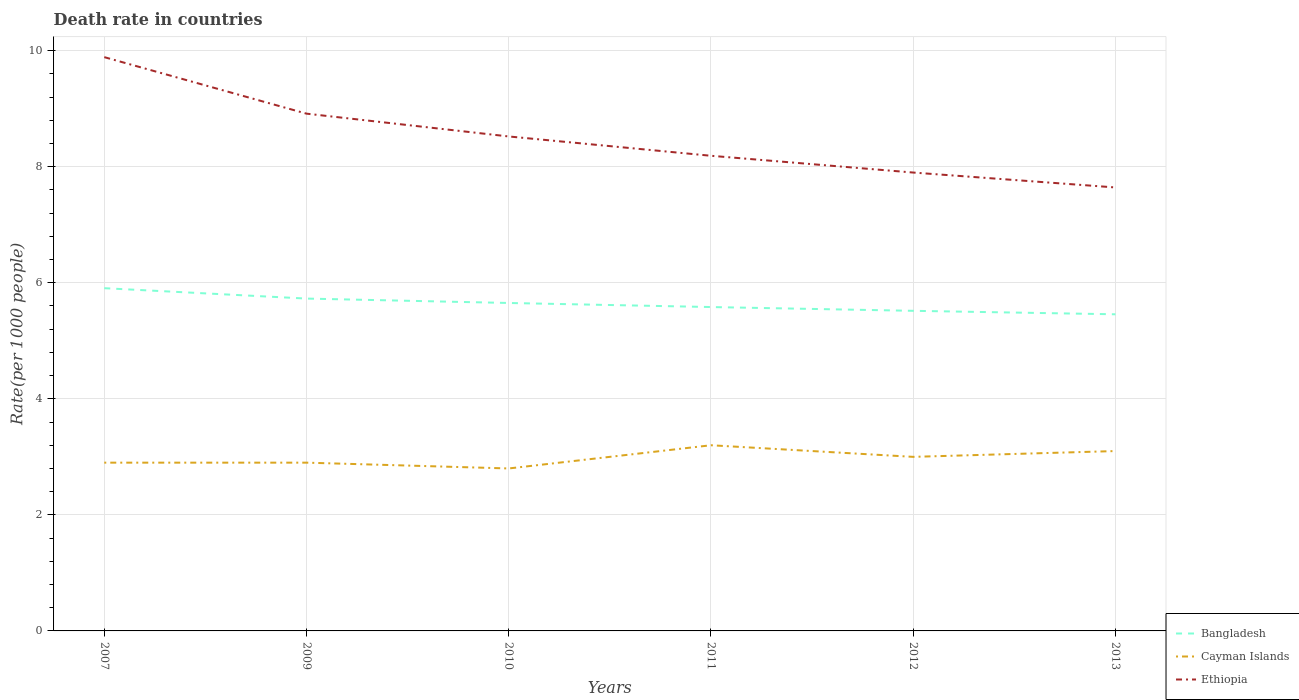How many different coloured lines are there?
Give a very brief answer. 3. Does the line corresponding to Bangladesh intersect with the line corresponding to Ethiopia?
Offer a terse response. No. Is the number of lines equal to the number of legend labels?
Ensure brevity in your answer.  Yes. Across all years, what is the maximum death rate in Cayman Islands?
Offer a very short reply. 2.8. In which year was the death rate in Cayman Islands maximum?
Ensure brevity in your answer.  2010. What is the total death rate in Cayman Islands in the graph?
Make the answer very short. -0.3. What is the difference between the highest and the second highest death rate in Bangladesh?
Make the answer very short. 0.45. How many years are there in the graph?
Offer a very short reply. 6. Are the values on the major ticks of Y-axis written in scientific E-notation?
Give a very brief answer. No. Does the graph contain any zero values?
Your response must be concise. No. Does the graph contain grids?
Give a very brief answer. Yes. What is the title of the graph?
Make the answer very short. Death rate in countries. What is the label or title of the Y-axis?
Offer a very short reply. Rate(per 1000 people). What is the Rate(per 1000 people) in Bangladesh in 2007?
Provide a succinct answer. 5.91. What is the Rate(per 1000 people) of Cayman Islands in 2007?
Keep it short and to the point. 2.9. What is the Rate(per 1000 people) in Ethiopia in 2007?
Your response must be concise. 9.89. What is the Rate(per 1000 people) of Bangladesh in 2009?
Your answer should be very brief. 5.73. What is the Rate(per 1000 people) in Cayman Islands in 2009?
Make the answer very short. 2.9. What is the Rate(per 1000 people) in Ethiopia in 2009?
Provide a short and direct response. 8.91. What is the Rate(per 1000 people) of Bangladesh in 2010?
Provide a short and direct response. 5.65. What is the Rate(per 1000 people) in Cayman Islands in 2010?
Keep it short and to the point. 2.8. What is the Rate(per 1000 people) of Ethiopia in 2010?
Offer a very short reply. 8.52. What is the Rate(per 1000 people) in Bangladesh in 2011?
Your answer should be very brief. 5.58. What is the Rate(per 1000 people) in Cayman Islands in 2011?
Keep it short and to the point. 3.2. What is the Rate(per 1000 people) in Ethiopia in 2011?
Your answer should be very brief. 8.19. What is the Rate(per 1000 people) of Bangladesh in 2012?
Offer a very short reply. 5.52. What is the Rate(per 1000 people) in Ethiopia in 2012?
Make the answer very short. 7.9. What is the Rate(per 1000 people) in Bangladesh in 2013?
Offer a very short reply. 5.46. What is the Rate(per 1000 people) in Ethiopia in 2013?
Provide a short and direct response. 7.64. Across all years, what is the maximum Rate(per 1000 people) in Bangladesh?
Your answer should be compact. 5.91. Across all years, what is the maximum Rate(per 1000 people) of Cayman Islands?
Give a very brief answer. 3.2. Across all years, what is the maximum Rate(per 1000 people) of Ethiopia?
Offer a terse response. 9.89. Across all years, what is the minimum Rate(per 1000 people) of Bangladesh?
Offer a very short reply. 5.46. Across all years, what is the minimum Rate(per 1000 people) in Ethiopia?
Your answer should be very brief. 7.64. What is the total Rate(per 1000 people) of Bangladesh in the graph?
Provide a succinct answer. 33.84. What is the total Rate(per 1000 people) in Cayman Islands in the graph?
Give a very brief answer. 17.9. What is the total Rate(per 1000 people) of Ethiopia in the graph?
Provide a short and direct response. 51.06. What is the difference between the Rate(per 1000 people) in Bangladesh in 2007 and that in 2009?
Provide a succinct answer. 0.18. What is the difference between the Rate(per 1000 people) of Cayman Islands in 2007 and that in 2009?
Provide a short and direct response. 0. What is the difference between the Rate(per 1000 people) in Ethiopia in 2007 and that in 2009?
Keep it short and to the point. 0.97. What is the difference between the Rate(per 1000 people) in Bangladesh in 2007 and that in 2010?
Your response must be concise. 0.26. What is the difference between the Rate(per 1000 people) of Ethiopia in 2007 and that in 2010?
Offer a very short reply. 1.37. What is the difference between the Rate(per 1000 people) of Bangladesh in 2007 and that in 2011?
Offer a very short reply. 0.33. What is the difference between the Rate(per 1000 people) of Cayman Islands in 2007 and that in 2011?
Provide a short and direct response. -0.3. What is the difference between the Rate(per 1000 people) in Ethiopia in 2007 and that in 2011?
Keep it short and to the point. 1.7. What is the difference between the Rate(per 1000 people) of Bangladesh in 2007 and that in 2012?
Your response must be concise. 0.39. What is the difference between the Rate(per 1000 people) in Cayman Islands in 2007 and that in 2012?
Offer a terse response. -0.1. What is the difference between the Rate(per 1000 people) of Ethiopia in 2007 and that in 2012?
Provide a succinct answer. 1.99. What is the difference between the Rate(per 1000 people) of Bangladesh in 2007 and that in 2013?
Keep it short and to the point. 0.45. What is the difference between the Rate(per 1000 people) of Ethiopia in 2007 and that in 2013?
Give a very brief answer. 2.25. What is the difference between the Rate(per 1000 people) in Bangladesh in 2009 and that in 2010?
Make the answer very short. 0.08. What is the difference between the Rate(per 1000 people) in Cayman Islands in 2009 and that in 2010?
Make the answer very short. 0.1. What is the difference between the Rate(per 1000 people) of Ethiopia in 2009 and that in 2010?
Make the answer very short. 0.39. What is the difference between the Rate(per 1000 people) in Bangladesh in 2009 and that in 2011?
Your response must be concise. 0.15. What is the difference between the Rate(per 1000 people) of Cayman Islands in 2009 and that in 2011?
Your answer should be compact. -0.3. What is the difference between the Rate(per 1000 people) in Ethiopia in 2009 and that in 2011?
Your answer should be very brief. 0.73. What is the difference between the Rate(per 1000 people) in Bangladesh in 2009 and that in 2012?
Provide a succinct answer. 0.21. What is the difference between the Rate(per 1000 people) in Cayman Islands in 2009 and that in 2012?
Offer a very short reply. -0.1. What is the difference between the Rate(per 1000 people) of Bangladesh in 2009 and that in 2013?
Offer a very short reply. 0.27. What is the difference between the Rate(per 1000 people) of Cayman Islands in 2009 and that in 2013?
Your answer should be compact. -0.2. What is the difference between the Rate(per 1000 people) of Ethiopia in 2009 and that in 2013?
Give a very brief answer. 1.27. What is the difference between the Rate(per 1000 people) in Bangladesh in 2010 and that in 2011?
Ensure brevity in your answer.  0.07. What is the difference between the Rate(per 1000 people) of Cayman Islands in 2010 and that in 2011?
Ensure brevity in your answer.  -0.4. What is the difference between the Rate(per 1000 people) in Ethiopia in 2010 and that in 2011?
Keep it short and to the point. 0.33. What is the difference between the Rate(per 1000 people) in Bangladesh in 2010 and that in 2012?
Give a very brief answer. 0.14. What is the difference between the Rate(per 1000 people) of Cayman Islands in 2010 and that in 2012?
Offer a very short reply. -0.2. What is the difference between the Rate(per 1000 people) of Ethiopia in 2010 and that in 2012?
Offer a very short reply. 0.62. What is the difference between the Rate(per 1000 people) in Bangladesh in 2010 and that in 2013?
Make the answer very short. 0.2. What is the difference between the Rate(per 1000 people) of Ethiopia in 2010 and that in 2013?
Give a very brief answer. 0.88. What is the difference between the Rate(per 1000 people) in Bangladesh in 2011 and that in 2012?
Provide a succinct answer. 0.07. What is the difference between the Rate(per 1000 people) of Ethiopia in 2011 and that in 2012?
Keep it short and to the point. 0.29. What is the difference between the Rate(per 1000 people) in Bangladesh in 2011 and that in 2013?
Your response must be concise. 0.12. What is the difference between the Rate(per 1000 people) in Ethiopia in 2011 and that in 2013?
Your answer should be compact. 0.55. What is the difference between the Rate(per 1000 people) in Bangladesh in 2012 and that in 2013?
Offer a very short reply. 0.06. What is the difference between the Rate(per 1000 people) of Cayman Islands in 2012 and that in 2013?
Your answer should be very brief. -0.1. What is the difference between the Rate(per 1000 people) in Ethiopia in 2012 and that in 2013?
Make the answer very short. 0.26. What is the difference between the Rate(per 1000 people) of Bangladesh in 2007 and the Rate(per 1000 people) of Cayman Islands in 2009?
Offer a very short reply. 3.01. What is the difference between the Rate(per 1000 people) in Bangladesh in 2007 and the Rate(per 1000 people) in Ethiopia in 2009?
Ensure brevity in your answer.  -3.01. What is the difference between the Rate(per 1000 people) in Cayman Islands in 2007 and the Rate(per 1000 people) in Ethiopia in 2009?
Your answer should be compact. -6.01. What is the difference between the Rate(per 1000 people) in Bangladesh in 2007 and the Rate(per 1000 people) in Cayman Islands in 2010?
Provide a short and direct response. 3.11. What is the difference between the Rate(per 1000 people) in Bangladesh in 2007 and the Rate(per 1000 people) in Ethiopia in 2010?
Offer a terse response. -2.62. What is the difference between the Rate(per 1000 people) of Cayman Islands in 2007 and the Rate(per 1000 people) of Ethiopia in 2010?
Give a very brief answer. -5.62. What is the difference between the Rate(per 1000 people) in Bangladesh in 2007 and the Rate(per 1000 people) in Cayman Islands in 2011?
Offer a very short reply. 2.71. What is the difference between the Rate(per 1000 people) of Bangladesh in 2007 and the Rate(per 1000 people) of Ethiopia in 2011?
Provide a short and direct response. -2.28. What is the difference between the Rate(per 1000 people) of Cayman Islands in 2007 and the Rate(per 1000 people) of Ethiopia in 2011?
Offer a very short reply. -5.29. What is the difference between the Rate(per 1000 people) of Bangladesh in 2007 and the Rate(per 1000 people) of Cayman Islands in 2012?
Make the answer very short. 2.91. What is the difference between the Rate(per 1000 people) in Bangladesh in 2007 and the Rate(per 1000 people) in Ethiopia in 2012?
Provide a succinct answer. -1.99. What is the difference between the Rate(per 1000 people) in Bangladesh in 2007 and the Rate(per 1000 people) in Cayman Islands in 2013?
Keep it short and to the point. 2.81. What is the difference between the Rate(per 1000 people) in Bangladesh in 2007 and the Rate(per 1000 people) in Ethiopia in 2013?
Make the answer very short. -1.74. What is the difference between the Rate(per 1000 people) of Cayman Islands in 2007 and the Rate(per 1000 people) of Ethiopia in 2013?
Your answer should be compact. -4.74. What is the difference between the Rate(per 1000 people) of Bangladesh in 2009 and the Rate(per 1000 people) of Cayman Islands in 2010?
Keep it short and to the point. 2.93. What is the difference between the Rate(per 1000 people) of Bangladesh in 2009 and the Rate(per 1000 people) of Ethiopia in 2010?
Your response must be concise. -2.79. What is the difference between the Rate(per 1000 people) in Cayman Islands in 2009 and the Rate(per 1000 people) in Ethiopia in 2010?
Your response must be concise. -5.62. What is the difference between the Rate(per 1000 people) of Bangladesh in 2009 and the Rate(per 1000 people) of Cayman Islands in 2011?
Your response must be concise. 2.53. What is the difference between the Rate(per 1000 people) in Bangladesh in 2009 and the Rate(per 1000 people) in Ethiopia in 2011?
Provide a short and direct response. -2.46. What is the difference between the Rate(per 1000 people) in Cayman Islands in 2009 and the Rate(per 1000 people) in Ethiopia in 2011?
Make the answer very short. -5.29. What is the difference between the Rate(per 1000 people) in Bangladesh in 2009 and the Rate(per 1000 people) in Cayman Islands in 2012?
Offer a terse response. 2.73. What is the difference between the Rate(per 1000 people) of Bangladesh in 2009 and the Rate(per 1000 people) of Ethiopia in 2012?
Your answer should be very brief. -2.17. What is the difference between the Rate(per 1000 people) of Bangladesh in 2009 and the Rate(per 1000 people) of Cayman Islands in 2013?
Offer a very short reply. 2.63. What is the difference between the Rate(per 1000 people) of Bangladesh in 2009 and the Rate(per 1000 people) of Ethiopia in 2013?
Your response must be concise. -1.92. What is the difference between the Rate(per 1000 people) in Cayman Islands in 2009 and the Rate(per 1000 people) in Ethiopia in 2013?
Make the answer very short. -4.74. What is the difference between the Rate(per 1000 people) of Bangladesh in 2010 and the Rate(per 1000 people) of Cayman Islands in 2011?
Provide a succinct answer. 2.45. What is the difference between the Rate(per 1000 people) in Bangladesh in 2010 and the Rate(per 1000 people) in Ethiopia in 2011?
Keep it short and to the point. -2.54. What is the difference between the Rate(per 1000 people) of Cayman Islands in 2010 and the Rate(per 1000 people) of Ethiopia in 2011?
Offer a very short reply. -5.39. What is the difference between the Rate(per 1000 people) of Bangladesh in 2010 and the Rate(per 1000 people) of Cayman Islands in 2012?
Your answer should be very brief. 2.65. What is the difference between the Rate(per 1000 people) in Bangladesh in 2010 and the Rate(per 1000 people) in Ethiopia in 2012?
Your response must be concise. -2.25. What is the difference between the Rate(per 1000 people) of Bangladesh in 2010 and the Rate(per 1000 people) of Cayman Islands in 2013?
Your answer should be compact. 2.55. What is the difference between the Rate(per 1000 people) in Bangladesh in 2010 and the Rate(per 1000 people) in Ethiopia in 2013?
Provide a succinct answer. -1.99. What is the difference between the Rate(per 1000 people) in Cayman Islands in 2010 and the Rate(per 1000 people) in Ethiopia in 2013?
Provide a succinct answer. -4.84. What is the difference between the Rate(per 1000 people) in Bangladesh in 2011 and the Rate(per 1000 people) in Cayman Islands in 2012?
Your answer should be compact. 2.58. What is the difference between the Rate(per 1000 people) in Bangladesh in 2011 and the Rate(per 1000 people) in Ethiopia in 2012?
Your response must be concise. -2.32. What is the difference between the Rate(per 1000 people) in Cayman Islands in 2011 and the Rate(per 1000 people) in Ethiopia in 2012?
Your answer should be very brief. -4.7. What is the difference between the Rate(per 1000 people) of Bangladesh in 2011 and the Rate(per 1000 people) of Cayman Islands in 2013?
Give a very brief answer. 2.48. What is the difference between the Rate(per 1000 people) in Bangladesh in 2011 and the Rate(per 1000 people) in Ethiopia in 2013?
Your answer should be very brief. -2.06. What is the difference between the Rate(per 1000 people) of Cayman Islands in 2011 and the Rate(per 1000 people) of Ethiopia in 2013?
Offer a terse response. -4.44. What is the difference between the Rate(per 1000 people) in Bangladesh in 2012 and the Rate(per 1000 people) in Cayman Islands in 2013?
Your answer should be compact. 2.42. What is the difference between the Rate(per 1000 people) in Bangladesh in 2012 and the Rate(per 1000 people) in Ethiopia in 2013?
Your answer should be very brief. -2.13. What is the difference between the Rate(per 1000 people) of Cayman Islands in 2012 and the Rate(per 1000 people) of Ethiopia in 2013?
Offer a terse response. -4.64. What is the average Rate(per 1000 people) in Bangladesh per year?
Offer a terse response. 5.64. What is the average Rate(per 1000 people) of Cayman Islands per year?
Keep it short and to the point. 2.98. What is the average Rate(per 1000 people) in Ethiopia per year?
Your response must be concise. 8.51. In the year 2007, what is the difference between the Rate(per 1000 people) in Bangladesh and Rate(per 1000 people) in Cayman Islands?
Ensure brevity in your answer.  3.01. In the year 2007, what is the difference between the Rate(per 1000 people) in Bangladesh and Rate(per 1000 people) in Ethiopia?
Offer a very short reply. -3.98. In the year 2007, what is the difference between the Rate(per 1000 people) in Cayman Islands and Rate(per 1000 people) in Ethiopia?
Your answer should be very brief. -6.99. In the year 2009, what is the difference between the Rate(per 1000 people) of Bangladesh and Rate(per 1000 people) of Cayman Islands?
Make the answer very short. 2.83. In the year 2009, what is the difference between the Rate(per 1000 people) of Bangladesh and Rate(per 1000 people) of Ethiopia?
Give a very brief answer. -3.19. In the year 2009, what is the difference between the Rate(per 1000 people) in Cayman Islands and Rate(per 1000 people) in Ethiopia?
Your answer should be compact. -6.01. In the year 2010, what is the difference between the Rate(per 1000 people) in Bangladesh and Rate(per 1000 people) in Cayman Islands?
Offer a terse response. 2.85. In the year 2010, what is the difference between the Rate(per 1000 people) of Bangladesh and Rate(per 1000 people) of Ethiopia?
Ensure brevity in your answer.  -2.87. In the year 2010, what is the difference between the Rate(per 1000 people) of Cayman Islands and Rate(per 1000 people) of Ethiopia?
Offer a terse response. -5.72. In the year 2011, what is the difference between the Rate(per 1000 people) of Bangladesh and Rate(per 1000 people) of Cayman Islands?
Offer a very short reply. 2.38. In the year 2011, what is the difference between the Rate(per 1000 people) in Bangladesh and Rate(per 1000 people) in Ethiopia?
Your answer should be very brief. -2.61. In the year 2011, what is the difference between the Rate(per 1000 people) of Cayman Islands and Rate(per 1000 people) of Ethiopia?
Offer a terse response. -4.99. In the year 2012, what is the difference between the Rate(per 1000 people) in Bangladesh and Rate(per 1000 people) in Cayman Islands?
Keep it short and to the point. 2.52. In the year 2012, what is the difference between the Rate(per 1000 people) in Bangladesh and Rate(per 1000 people) in Ethiopia?
Your answer should be compact. -2.38. In the year 2012, what is the difference between the Rate(per 1000 people) in Cayman Islands and Rate(per 1000 people) in Ethiopia?
Your response must be concise. -4.9. In the year 2013, what is the difference between the Rate(per 1000 people) of Bangladesh and Rate(per 1000 people) of Cayman Islands?
Ensure brevity in your answer.  2.36. In the year 2013, what is the difference between the Rate(per 1000 people) of Bangladesh and Rate(per 1000 people) of Ethiopia?
Your answer should be compact. -2.19. In the year 2013, what is the difference between the Rate(per 1000 people) in Cayman Islands and Rate(per 1000 people) in Ethiopia?
Make the answer very short. -4.54. What is the ratio of the Rate(per 1000 people) in Bangladesh in 2007 to that in 2009?
Your response must be concise. 1.03. What is the ratio of the Rate(per 1000 people) in Ethiopia in 2007 to that in 2009?
Give a very brief answer. 1.11. What is the ratio of the Rate(per 1000 people) of Bangladesh in 2007 to that in 2010?
Your response must be concise. 1.05. What is the ratio of the Rate(per 1000 people) of Cayman Islands in 2007 to that in 2010?
Give a very brief answer. 1.04. What is the ratio of the Rate(per 1000 people) of Ethiopia in 2007 to that in 2010?
Your answer should be very brief. 1.16. What is the ratio of the Rate(per 1000 people) in Bangladesh in 2007 to that in 2011?
Ensure brevity in your answer.  1.06. What is the ratio of the Rate(per 1000 people) in Cayman Islands in 2007 to that in 2011?
Offer a terse response. 0.91. What is the ratio of the Rate(per 1000 people) of Ethiopia in 2007 to that in 2011?
Offer a very short reply. 1.21. What is the ratio of the Rate(per 1000 people) of Bangladesh in 2007 to that in 2012?
Provide a short and direct response. 1.07. What is the ratio of the Rate(per 1000 people) of Cayman Islands in 2007 to that in 2012?
Your answer should be very brief. 0.97. What is the ratio of the Rate(per 1000 people) in Ethiopia in 2007 to that in 2012?
Offer a terse response. 1.25. What is the ratio of the Rate(per 1000 people) in Bangladesh in 2007 to that in 2013?
Give a very brief answer. 1.08. What is the ratio of the Rate(per 1000 people) in Cayman Islands in 2007 to that in 2013?
Provide a short and direct response. 0.94. What is the ratio of the Rate(per 1000 people) in Ethiopia in 2007 to that in 2013?
Ensure brevity in your answer.  1.29. What is the ratio of the Rate(per 1000 people) of Bangladesh in 2009 to that in 2010?
Offer a very short reply. 1.01. What is the ratio of the Rate(per 1000 people) in Cayman Islands in 2009 to that in 2010?
Keep it short and to the point. 1.04. What is the ratio of the Rate(per 1000 people) of Ethiopia in 2009 to that in 2010?
Offer a very short reply. 1.05. What is the ratio of the Rate(per 1000 people) of Bangladesh in 2009 to that in 2011?
Make the answer very short. 1.03. What is the ratio of the Rate(per 1000 people) of Cayman Islands in 2009 to that in 2011?
Keep it short and to the point. 0.91. What is the ratio of the Rate(per 1000 people) in Ethiopia in 2009 to that in 2011?
Offer a very short reply. 1.09. What is the ratio of the Rate(per 1000 people) in Bangladesh in 2009 to that in 2012?
Make the answer very short. 1.04. What is the ratio of the Rate(per 1000 people) in Cayman Islands in 2009 to that in 2012?
Keep it short and to the point. 0.97. What is the ratio of the Rate(per 1000 people) in Ethiopia in 2009 to that in 2012?
Provide a short and direct response. 1.13. What is the ratio of the Rate(per 1000 people) in Bangladesh in 2009 to that in 2013?
Provide a short and direct response. 1.05. What is the ratio of the Rate(per 1000 people) of Cayman Islands in 2009 to that in 2013?
Keep it short and to the point. 0.94. What is the ratio of the Rate(per 1000 people) in Ethiopia in 2009 to that in 2013?
Make the answer very short. 1.17. What is the ratio of the Rate(per 1000 people) in Bangladesh in 2010 to that in 2011?
Your answer should be very brief. 1.01. What is the ratio of the Rate(per 1000 people) of Cayman Islands in 2010 to that in 2011?
Give a very brief answer. 0.88. What is the ratio of the Rate(per 1000 people) in Ethiopia in 2010 to that in 2011?
Offer a terse response. 1.04. What is the ratio of the Rate(per 1000 people) in Bangladesh in 2010 to that in 2012?
Ensure brevity in your answer.  1.02. What is the ratio of the Rate(per 1000 people) in Ethiopia in 2010 to that in 2012?
Your response must be concise. 1.08. What is the ratio of the Rate(per 1000 people) in Bangladesh in 2010 to that in 2013?
Provide a succinct answer. 1.04. What is the ratio of the Rate(per 1000 people) of Cayman Islands in 2010 to that in 2013?
Ensure brevity in your answer.  0.9. What is the ratio of the Rate(per 1000 people) in Ethiopia in 2010 to that in 2013?
Your answer should be compact. 1.11. What is the ratio of the Rate(per 1000 people) of Bangladesh in 2011 to that in 2012?
Provide a succinct answer. 1.01. What is the ratio of the Rate(per 1000 people) of Cayman Islands in 2011 to that in 2012?
Provide a succinct answer. 1.07. What is the ratio of the Rate(per 1000 people) of Ethiopia in 2011 to that in 2012?
Offer a terse response. 1.04. What is the ratio of the Rate(per 1000 people) of Bangladesh in 2011 to that in 2013?
Offer a very short reply. 1.02. What is the ratio of the Rate(per 1000 people) of Cayman Islands in 2011 to that in 2013?
Offer a very short reply. 1.03. What is the ratio of the Rate(per 1000 people) in Ethiopia in 2011 to that in 2013?
Provide a succinct answer. 1.07. What is the ratio of the Rate(per 1000 people) in Bangladesh in 2012 to that in 2013?
Give a very brief answer. 1.01. What is the ratio of the Rate(per 1000 people) of Cayman Islands in 2012 to that in 2013?
Keep it short and to the point. 0.97. What is the ratio of the Rate(per 1000 people) in Ethiopia in 2012 to that in 2013?
Keep it short and to the point. 1.03. What is the difference between the highest and the second highest Rate(per 1000 people) of Bangladesh?
Offer a terse response. 0.18. What is the difference between the highest and the second highest Rate(per 1000 people) in Cayman Islands?
Offer a terse response. 0.1. What is the difference between the highest and the lowest Rate(per 1000 people) in Bangladesh?
Your answer should be compact. 0.45. What is the difference between the highest and the lowest Rate(per 1000 people) in Cayman Islands?
Your answer should be very brief. 0.4. What is the difference between the highest and the lowest Rate(per 1000 people) in Ethiopia?
Ensure brevity in your answer.  2.25. 